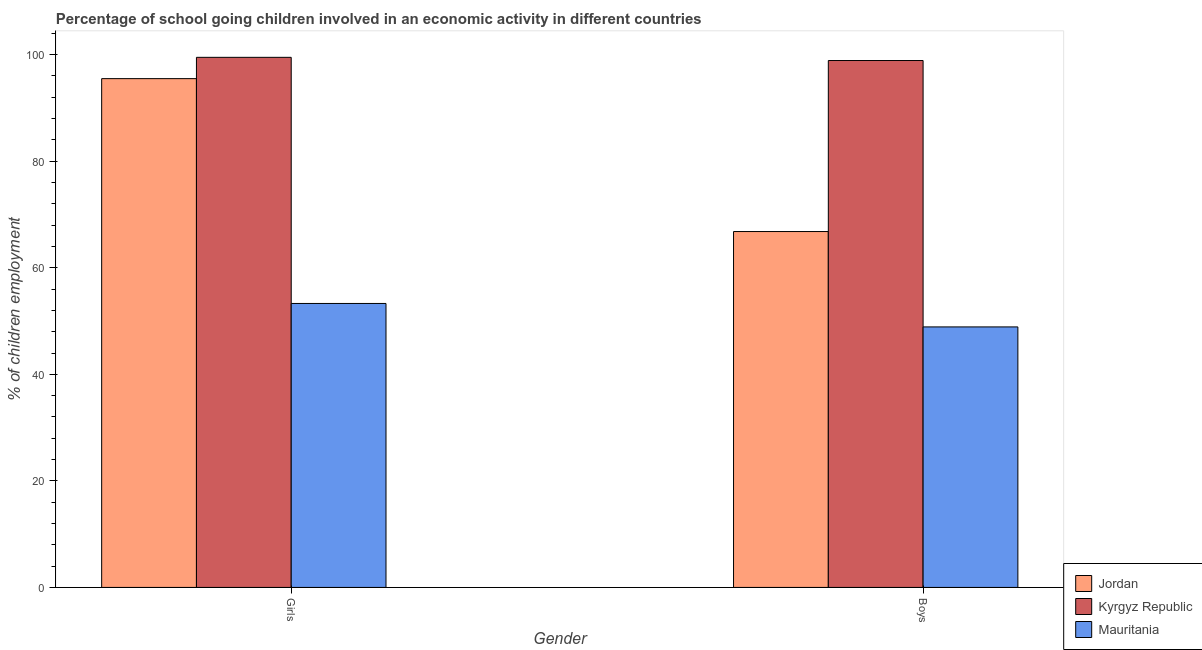What is the label of the 1st group of bars from the left?
Your response must be concise. Girls. What is the percentage of school going girls in Kyrgyz Republic?
Offer a terse response. 99.5. Across all countries, what is the maximum percentage of school going boys?
Provide a succinct answer. 98.9. Across all countries, what is the minimum percentage of school going girls?
Offer a terse response. 53.3. In which country was the percentage of school going boys maximum?
Make the answer very short. Kyrgyz Republic. In which country was the percentage of school going boys minimum?
Your answer should be compact. Mauritania. What is the total percentage of school going boys in the graph?
Your answer should be compact. 214.6. What is the difference between the percentage of school going girls in Kyrgyz Republic and that in Mauritania?
Offer a terse response. 46.2. What is the difference between the percentage of school going boys in Jordan and the percentage of school going girls in Kyrgyz Republic?
Your answer should be compact. -32.7. What is the average percentage of school going boys per country?
Your answer should be very brief. 71.53. What is the difference between the percentage of school going boys and percentage of school going girls in Kyrgyz Republic?
Provide a short and direct response. -0.6. In how many countries, is the percentage of school going girls greater than 64 %?
Provide a succinct answer. 2. What is the ratio of the percentage of school going boys in Jordan to that in Kyrgyz Republic?
Ensure brevity in your answer.  0.68. Is the percentage of school going girls in Jordan less than that in Mauritania?
Your answer should be very brief. No. What does the 2nd bar from the left in Boys represents?
Keep it short and to the point. Kyrgyz Republic. What does the 2nd bar from the right in Boys represents?
Ensure brevity in your answer.  Kyrgyz Republic. How many bars are there?
Give a very brief answer. 6. How many countries are there in the graph?
Offer a terse response. 3. Are the values on the major ticks of Y-axis written in scientific E-notation?
Your response must be concise. No. Does the graph contain any zero values?
Make the answer very short. No. How many legend labels are there?
Your response must be concise. 3. How are the legend labels stacked?
Ensure brevity in your answer.  Vertical. What is the title of the graph?
Make the answer very short. Percentage of school going children involved in an economic activity in different countries. What is the label or title of the X-axis?
Provide a succinct answer. Gender. What is the label or title of the Y-axis?
Provide a short and direct response. % of children employment. What is the % of children employment in Jordan in Girls?
Ensure brevity in your answer.  95.5. What is the % of children employment of Kyrgyz Republic in Girls?
Give a very brief answer. 99.5. What is the % of children employment of Mauritania in Girls?
Your answer should be compact. 53.3. What is the % of children employment of Jordan in Boys?
Keep it short and to the point. 66.8. What is the % of children employment of Kyrgyz Republic in Boys?
Make the answer very short. 98.9. What is the % of children employment of Mauritania in Boys?
Offer a terse response. 48.9. Across all Gender, what is the maximum % of children employment of Jordan?
Offer a terse response. 95.5. Across all Gender, what is the maximum % of children employment of Kyrgyz Republic?
Provide a succinct answer. 99.5. Across all Gender, what is the maximum % of children employment in Mauritania?
Ensure brevity in your answer.  53.3. Across all Gender, what is the minimum % of children employment in Jordan?
Provide a succinct answer. 66.8. Across all Gender, what is the minimum % of children employment of Kyrgyz Republic?
Offer a terse response. 98.9. Across all Gender, what is the minimum % of children employment of Mauritania?
Offer a very short reply. 48.9. What is the total % of children employment of Jordan in the graph?
Keep it short and to the point. 162.3. What is the total % of children employment of Kyrgyz Republic in the graph?
Give a very brief answer. 198.4. What is the total % of children employment of Mauritania in the graph?
Your answer should be very brief. 102.2. What is the difference between the % of children employment of Jordan in Girls and that in Boys?
Offer a very short reply. 28.7. What is the difference between the % of children employment in Kyrgyz Republic in Girls and that in Boys?
Provide a succinct answer. 0.6. What is the difference between the % of children employment in Jordan in Girls and the % of children employment in Kyrgyz Republic in Boys?
Offer a terse response. -3.4. What is the difference between the % of children employment in Jordan in Girls and the % of children employment in Mauritania in Boys?
Provide a succinct answer. 46.6. What is the difference between the % of children employment of Kyrgyz Republic in Girls and the % of children employment of Mauritania in Boys?
Your response must be concise. 50.6. What is the average % of children employment of Jordan per Gender?
Give a very brief answer. 81.15. What is the average % of children employment in Kyrgyz Republic per Gender?
Make the answer very short. 99.2. What is the average % of children employment in Mauritania per Gender?
Keep it short and to the point. 51.1. What is the difference between the % of children employment of Jordan and % of children employment of Mauritania in Girls?
Your answer should be very brief. 42.2. What is the difference between the % of children employment in Kyrgyz Republic and % of children employment in Mauritania in Girls?
Offer a terse response. 46.2. What is the difference between the % of children employment in Jordan and % of children employment in Kyrgyz Republic in Boys?
Offer a terse response. -32.1. What is the difference between the % of children employment of Jordan and % of children employment of Mauritania in Boys?
Your answer should be compact. 17.9. What is the difference between the % of children employment in Kyrgyz Republic and % of children employment in Mauritania in Boys?
Your answer should be very brief. 50. What is the ratio of the % of children employment in Jordan in Girls to that in Boys?
Give a very brief answer. 1.43. What is the ratio of the % of children employment of Kyrgyz Republic in Girls to that in Boys?
Provide a short and direct response. 1.01. What is the ratio of the % of children employment in Mauritania in Girls to that in Boys?
Your answer should be compact. 1.09. What is the difference between the highest and the second highest % of children employment in Jordan?
Offer a very short reply. 28.7. What is the difference between the highest and the second highest % of children employment in Kyrgyz Republic?
Offer a terse response. 0.6. What is the difference between the highest and the lowest % of children employment of Jordan?
Provide a short and direct response. 28.7. 